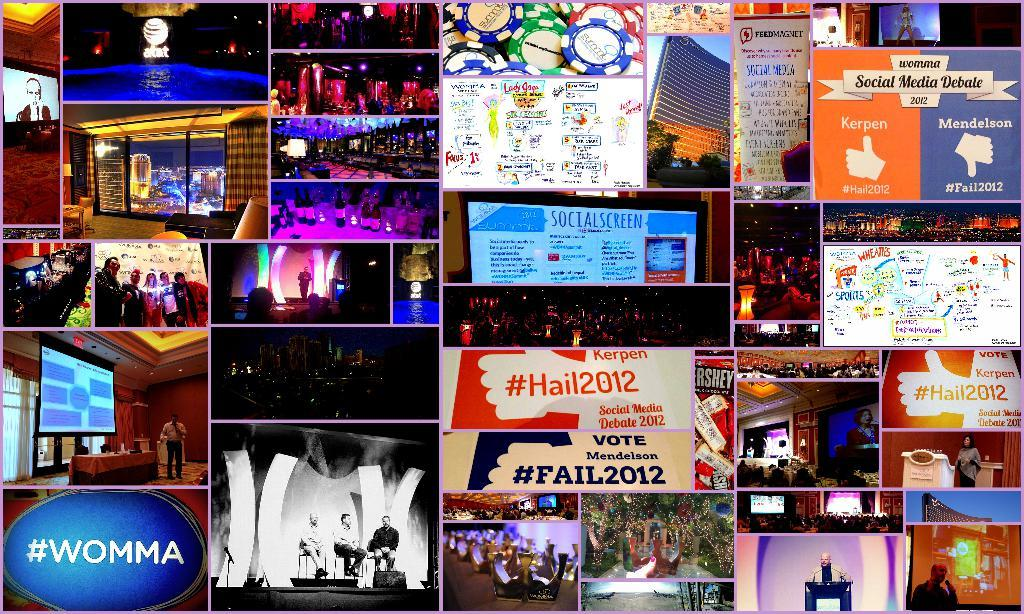<image>
Share a concise interpretation of the image provided. A collage of images includes the hashtag #WOMMA. 